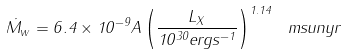<formula> <loc_0><loc_0><loc_500><loc_500>\dot { M } _ { w } = 6 . 4 \times 1 0 ^ { - 9 } A \left ( \frac { L _ { X } } { 1 0 ^ { 3 0 } e r g s ^ { - 1 } } \right ) ^ { 1 . 1 4 } \ m s u n y r</formula> 